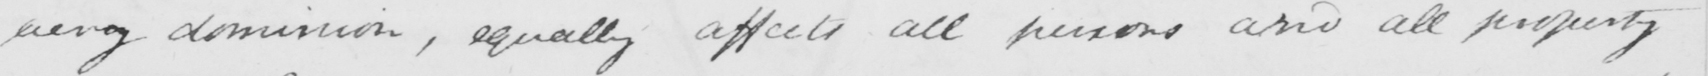Can you read and transcribe this handwriting? every dominion , equally affects all persons and all property 